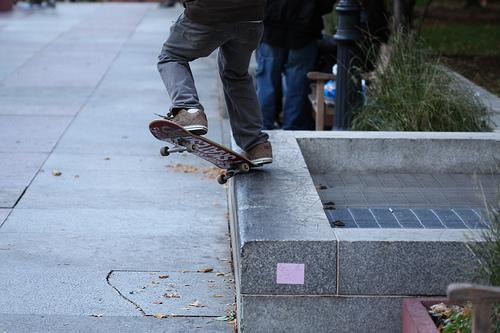Question: what is the person wearing the grey pants doing?
Choices:
A. Running.
B. Standing.
C. Skateboarding.
D. Talking.
Answer with the letter. Answer: C Question: what is the person in the grey pants standing on?
Choices:
A. A bench.
B. Skateboard.
C. The ground.
D. The grass.
Answer with the letter. Answer: B Question: what color are the skateboarder's shoes?
Choices:
A. Black.
B. Brown.
C. Red.
D. Blue.
Answer with the letter. Answer: B Question: what color are the skateboarder's pants?
Choices:
A. White.
B. Grey.
C. Black.
D. Brown.
Answer with the letter. Answer: B Question: who is on the ledge?
Choices:
A. A jumper.
B. Skateboarder.
C. An accountant.
D. A man.
Answer with the letter. Answer: B Question: what kind of pants is the person in the background wearing?
Choices:
A. Jeans.
B. Khakis.
C. Slacks.
D. Corduroys.
Answer with the letter. Answer: A 